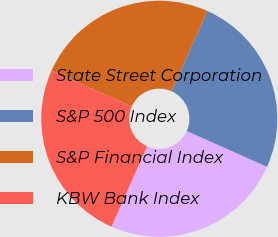Convert chart. <chart><loc_0><loc_0><loc_500><loc_500><pie_chart><fcel>State Street Corporation<fcel>S&P 500 Index<fcel>S&P Financial Index<fcel>KBW Bank Index<nl><fcel>24.96%<fcel>24.99%<fcel>25.01%<fcel>25.04%<nl></chart> 